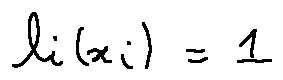<formula> <loc_0><loc_0><loc_500><loc_500>l _ { i } ( x _ { i } ) = 1</formula> 